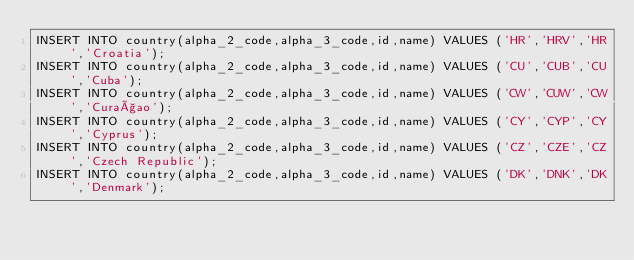<code> <loc_0><loc_0><loc_500><loc_500><_SQL_>INSERT INTO country(alpha_2_code,alpha_3_code,id,name) VALUES ('HR','HRV','HR','Croatia');
INSERT INTO country(alpha_2_code,alpha_3_code,id,name) VALUES ('CU','CUB','CU','Cuba');
INSERT INTO country(alpha_2_code,alpha_3_code,id,name) VALUES ('CW','CUW','CW','Curaçao');
INSERT INTO country(alpha_2_code,alpha_3_code,id,name) VALUES ('CY','CYP','CY','Cyprus');
INSERT INTO country(alpha_2_code,alpha_3_code,id,name) VALUES ('CZ','CZE','CZ','Czech Republic');
INSERT INTO country(alpha_2_code,alpha_3_code,id,name) VALUES ('DK','DNK','DK','Denmark');</code> 